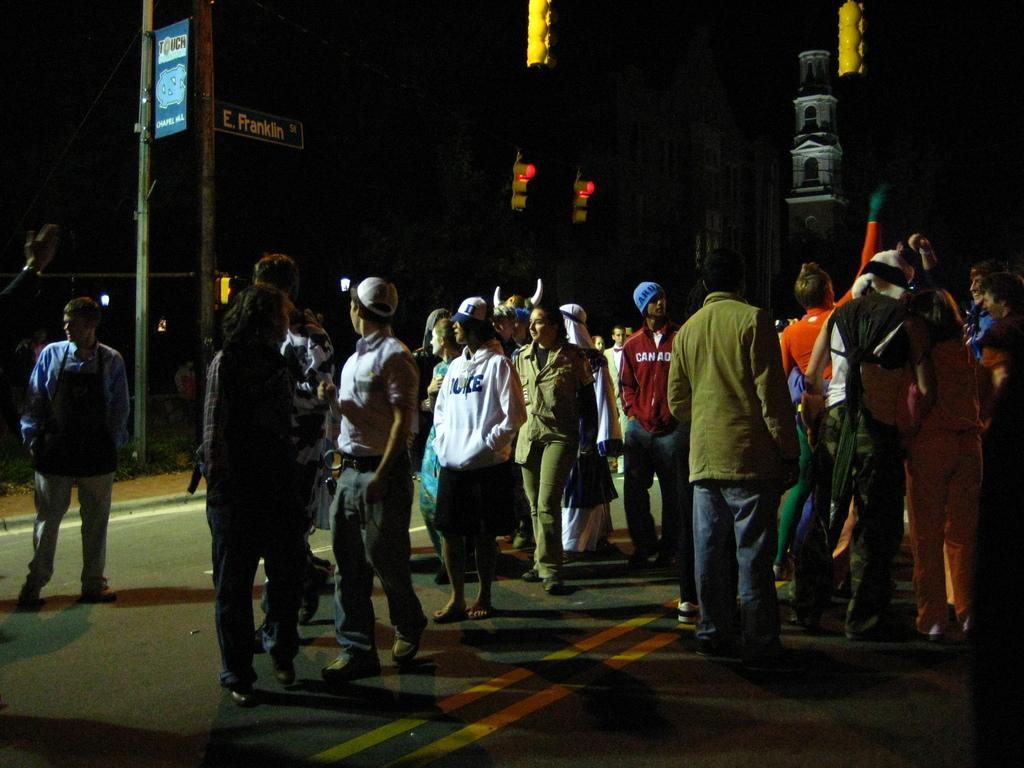Can you describe this image briefly? In this picture we can see the group of persons were standing on the road. On the left there is a man who is wearing shirt and shoe. In the background we can see pole and buildings. 